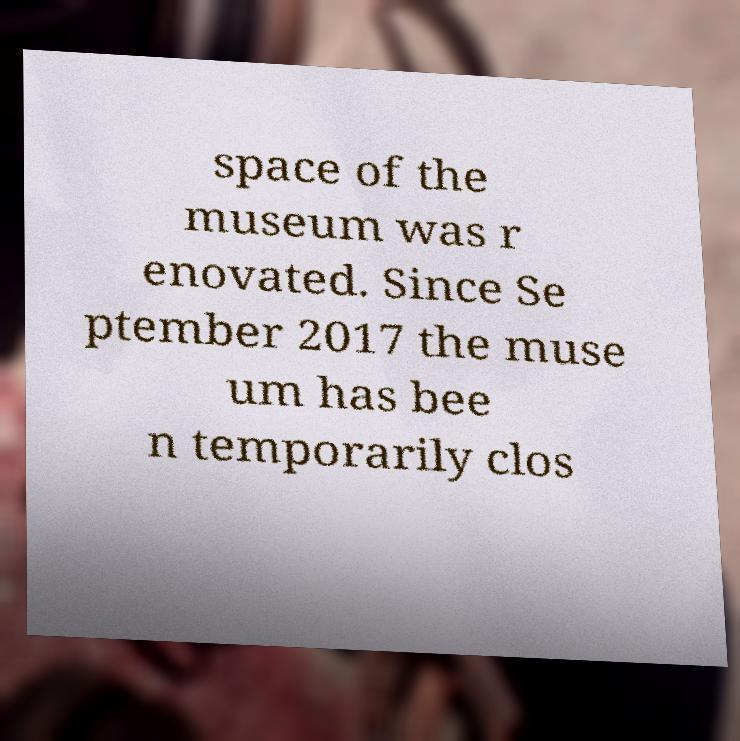Please read and relay the text visible in this image. What does it say? space of the museum was r enovated. Since Se ptember 2017 the muse um has bee n temporarily clos 